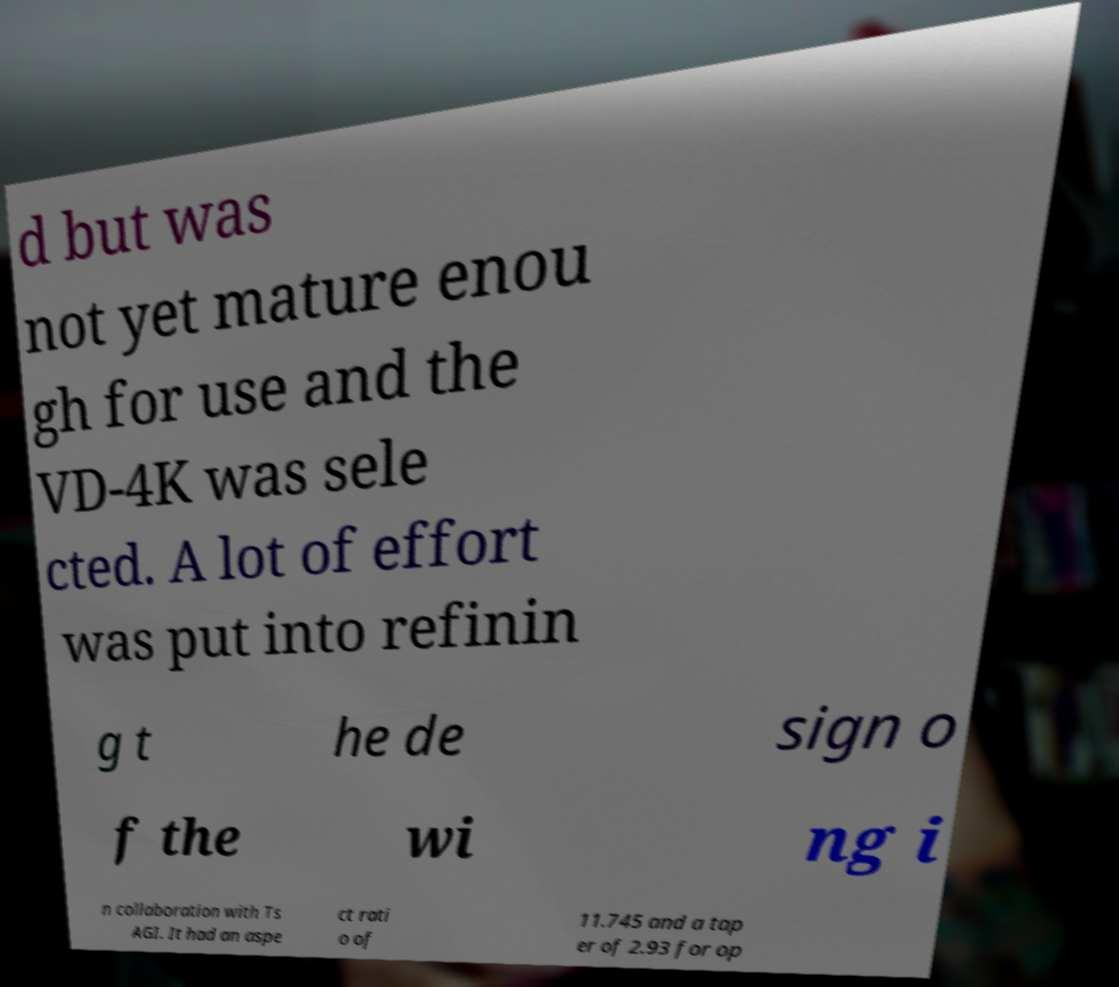There's text embedded in this image that I need extracted. Can you transcribe it verbatim? d but was not yet mature enou gh for use and the VD-4K was sele cted. A lot of effort was put into refinin g t he de sign o f the wi ng i n collaboration with Ts AGI. It had an aspe ct rati o of 11.745 and a tap er of 2.93 for op 